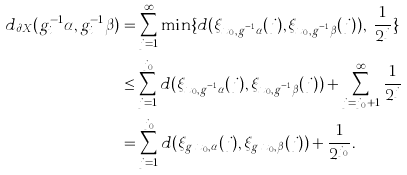<formula> <loc_0><loc_0><loc_500><loc_500>d _ { \partial X } ( g _ { i } ^ { - 1 } \alpha , g _ { i } ^ { - 1 } \beta ) & = \sum _ { j = 1 } ^ { \infty } \min \{ d ( \xi _ { x _ { 0 } , g _ { i } ^ { - 1 } \alpha } ( j ) , \xi _ { x _ { 0 } , g _ { i } ^ { - 1 } \beta } ( j ) ) , \ \frac { 1 } { 2 ^ { j } } \} \\ & \leq \sum _ { j = 1 } ^ { j _ { 0 } } d ( \xi _ { x _ { 0 } , g _ { i } ^ { - 1 } \alpha } ( j ) , \xi _ { x _ { 0 } , g _ { i } ^ { - 1 } \beta } ( j ) ) + \sum _ { j = j _ { 0 } + 1 } ^ { \infty } \frac { 1 } { 2 ^ { j } } \\ & = \sum _ { j = 1 } ^ { j _ { 0 } } d ( \xi _ { g _ { i } x _ { 0 } , \alpha } ( j ) , \xi _ { g _ { i } x _ { 0 } , \beta } ( j ) ) + \frac { 1 } { 2 ^ { j _ { 0 } } } .</formula> 